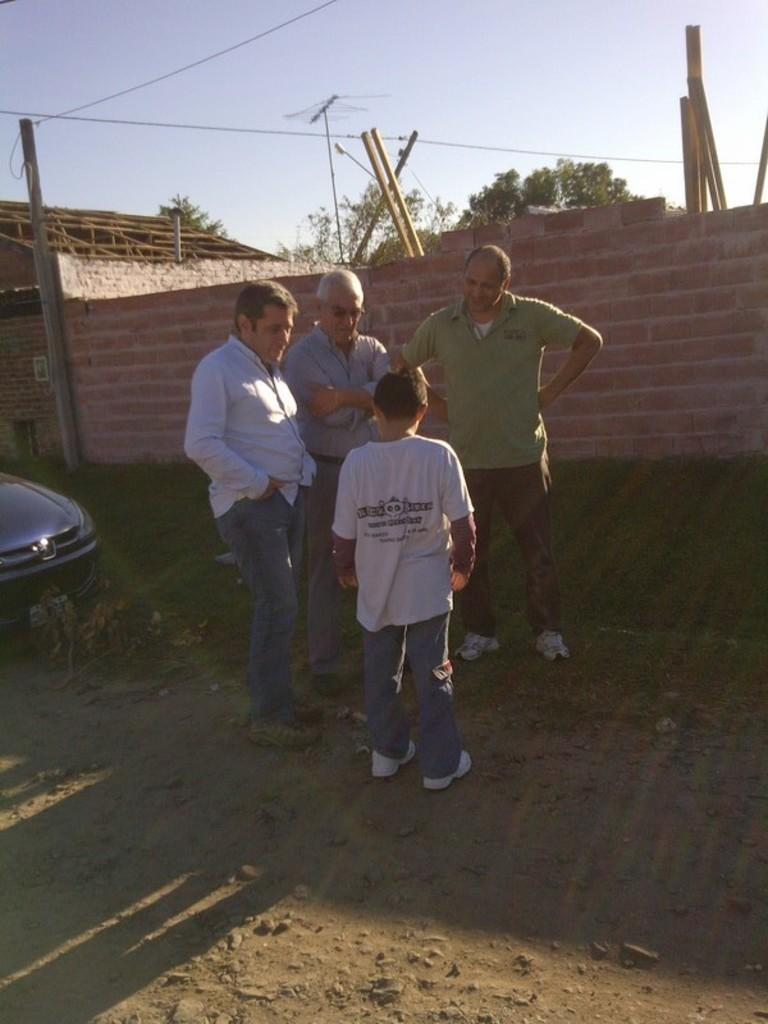What can be seen in the image involving people? There are people standing in the image. What is located on the left side of the image? There is a car on the left side of the image. What type of structure is present in the image? There is a brick wall in the image. What natural element is visible in the image? There is a tree in the image. What is visible at the top of the image? The sky is visible at the top of the image. Can you tell me how deep the hole is in the image? There is no hole present in the image. What type of current is flowing through the tree in the image? There is no current present in the image, as it is a tree and not an electrical device. 